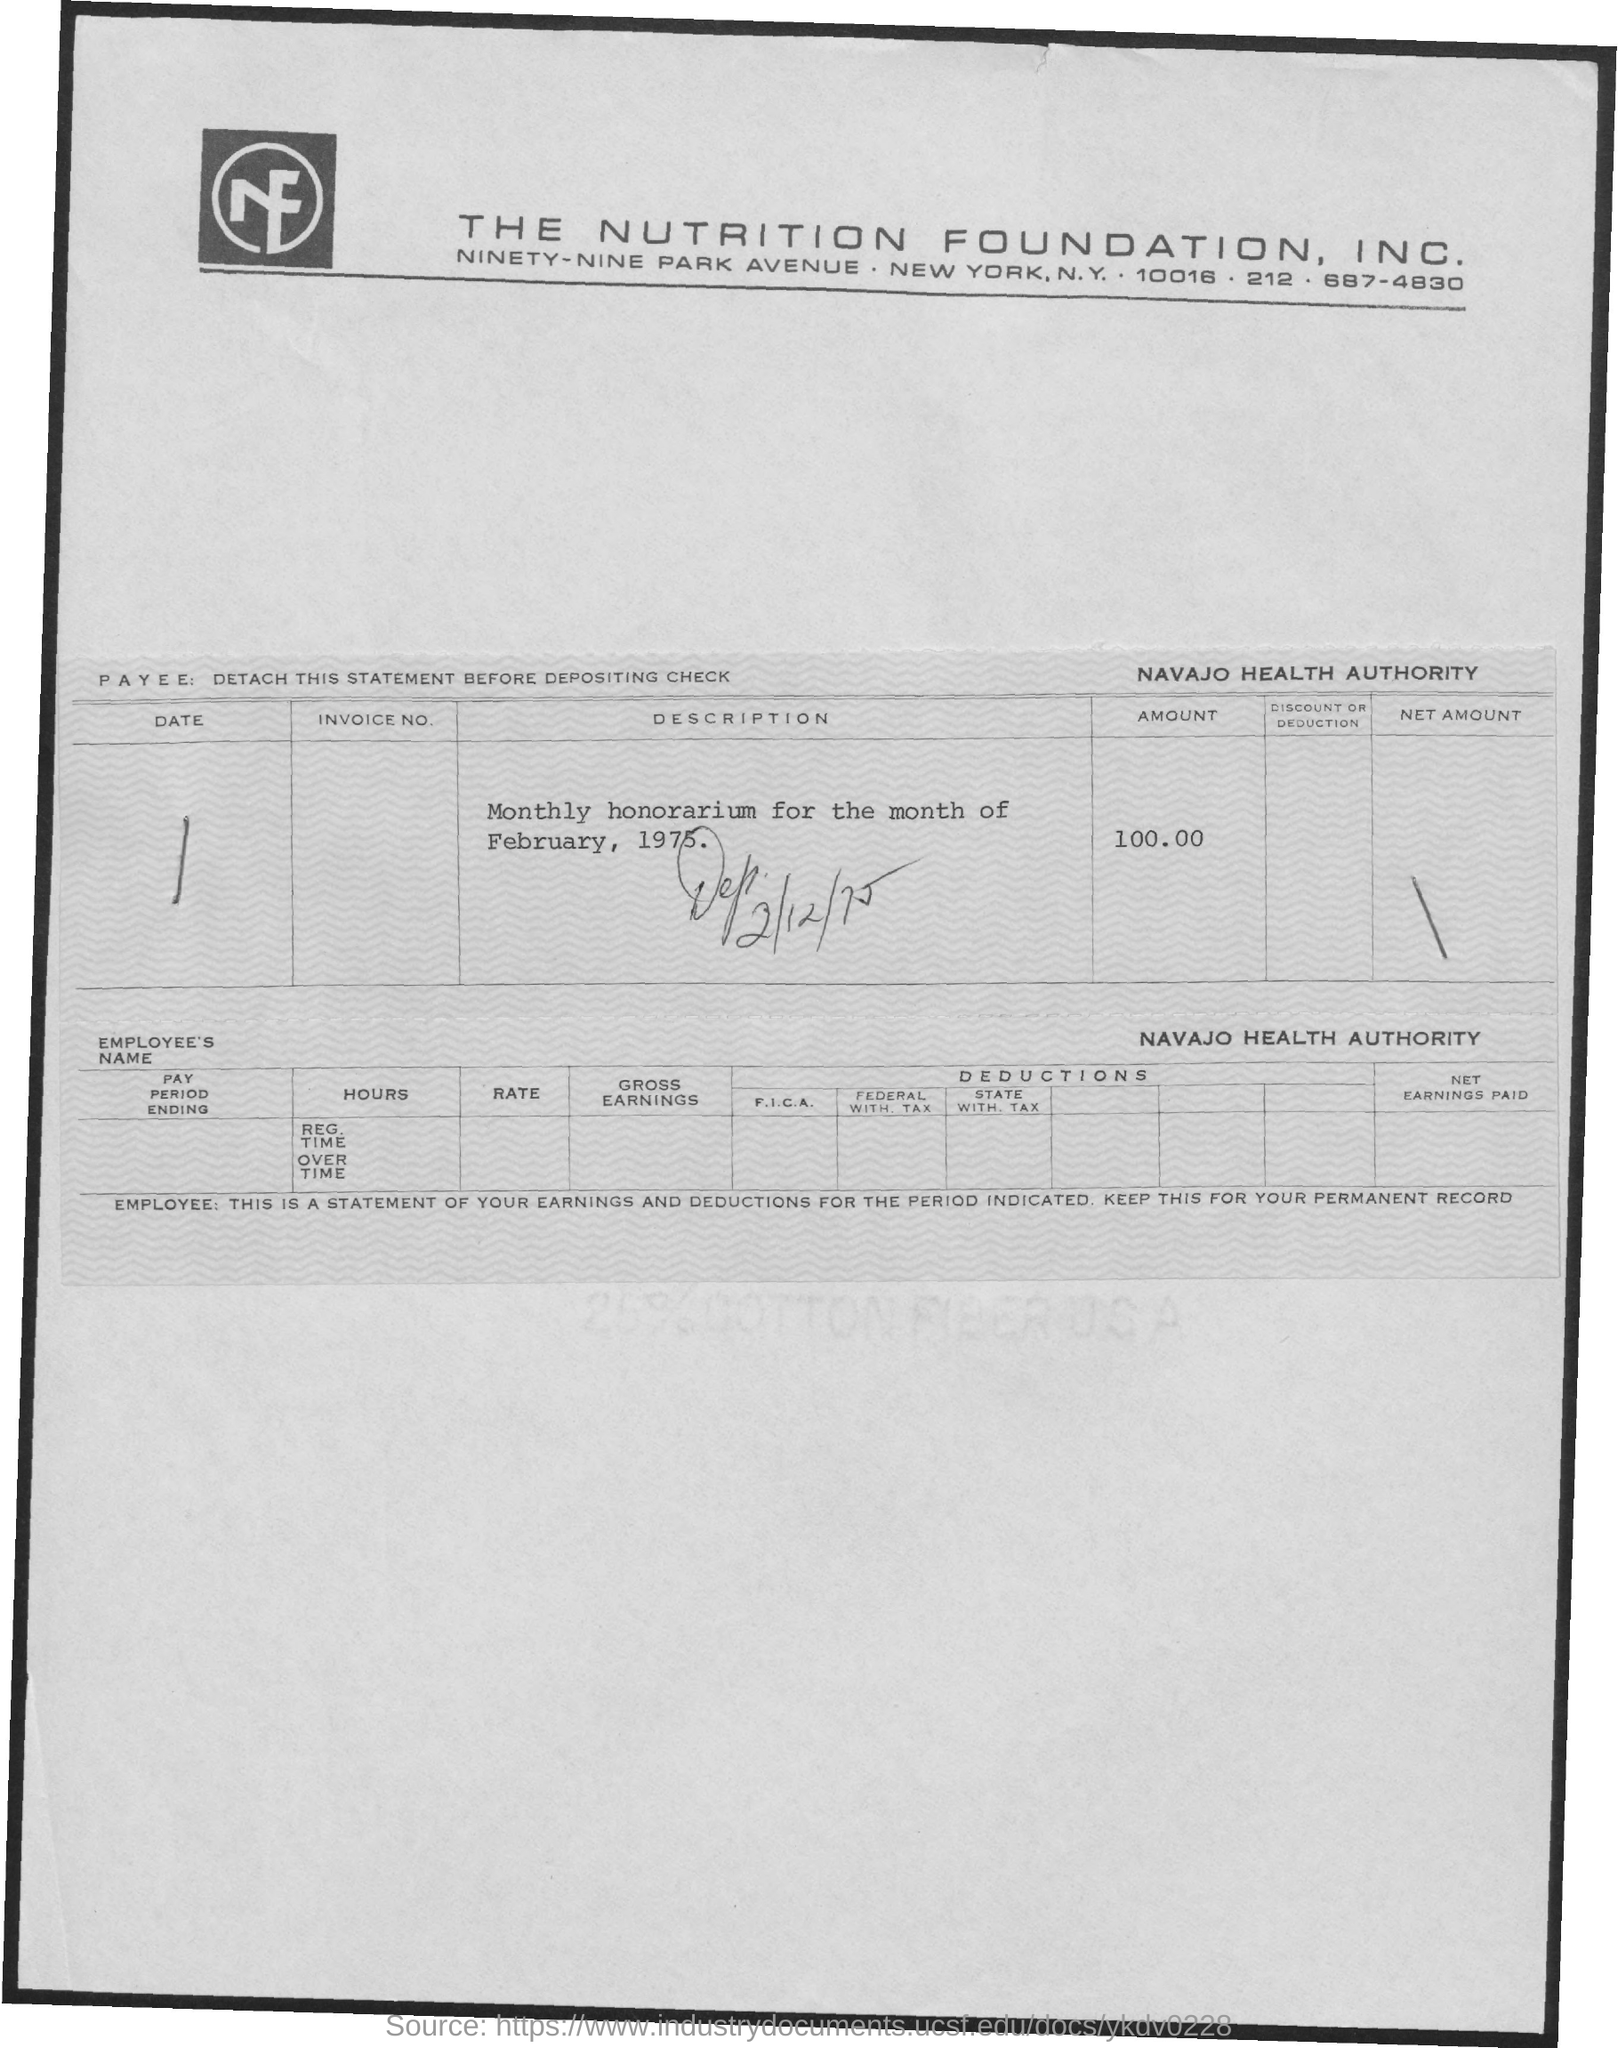List a handful of essential elements in this visual. The amount of the monthly honorarium for the month of February, 1975, was 100. The Navajo Health Authority is the name of the health authority. Nutrition Foundation" is a full-form and it is an acronym that stands for "Nutrition Foundation". The telephone number of the Nutrition Foundation Inc. is 687-4830. 